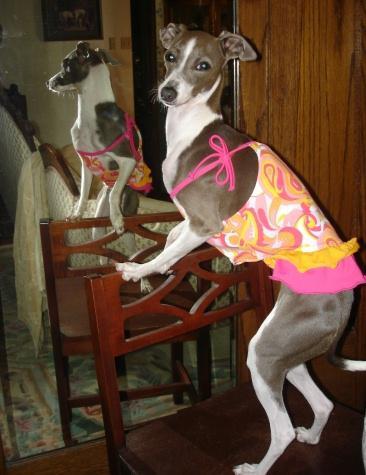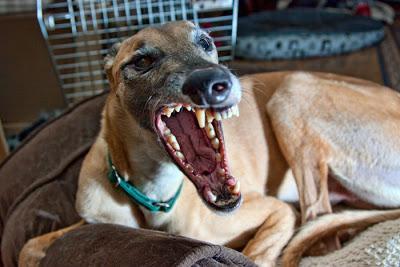The first image is the image on the left, the second image is the image on the right. Considering the images on both sides, is "One image features a hound wearing a hat, and no image shows more than one hound figure." valid? Answer yes or no. No. The first image is the image on the left, the second image is the image on the right. Considering the images on both sides, is "At least one of the dogs has a hat on its head." valid? Answer yes or no. No. 